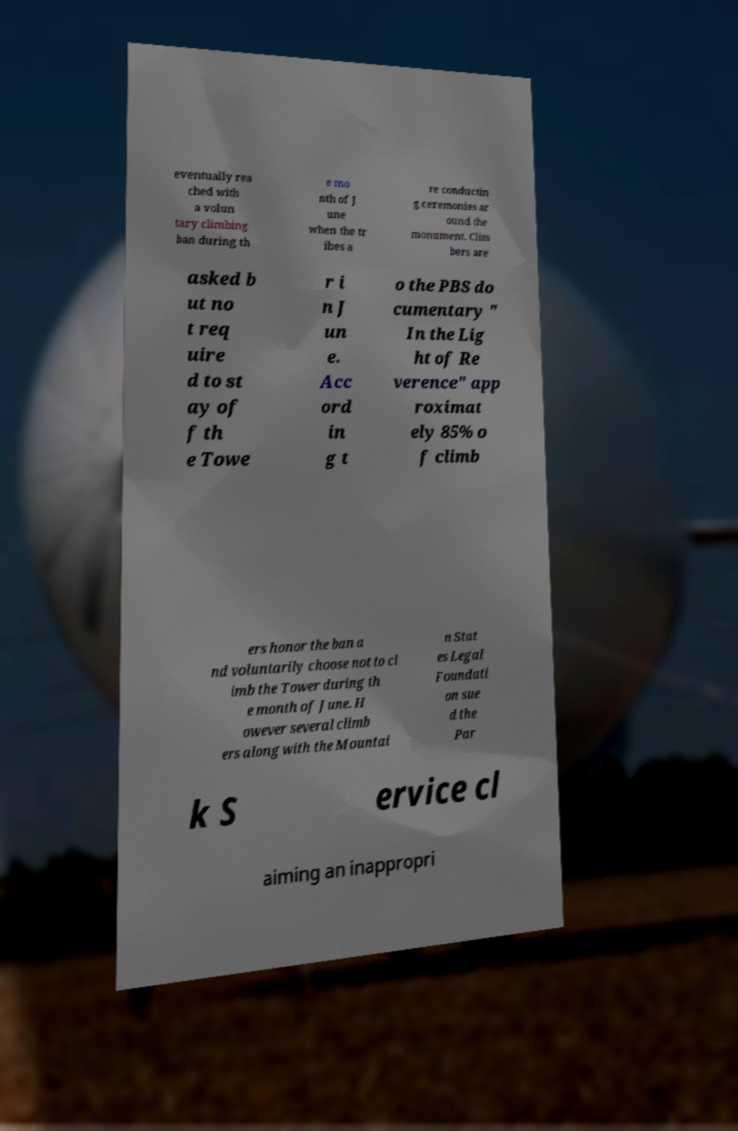Could you assist in decoding the text presented in this image and type it out clearly? eventually rea ched with a volun tary climbing ban during th e mo nth of J une when the tr ibes a re conductin g ceremonies ar ound the monument. Clim bers are asked b ut no t req uire d to st ay of f th e Towe r i n J un e. Acc ord in g t o the PBS do cumentary " In the Lig ht of Re verence" app roximat ely 85% o f climb ers honor the ban a nd voluntarily choose not to cl imb the Tower during th e month of June. H owever several climb ers along with the Mountai n Stat es Legal Foundati on sue d the Par k S ervice cl aiming an inappropri 